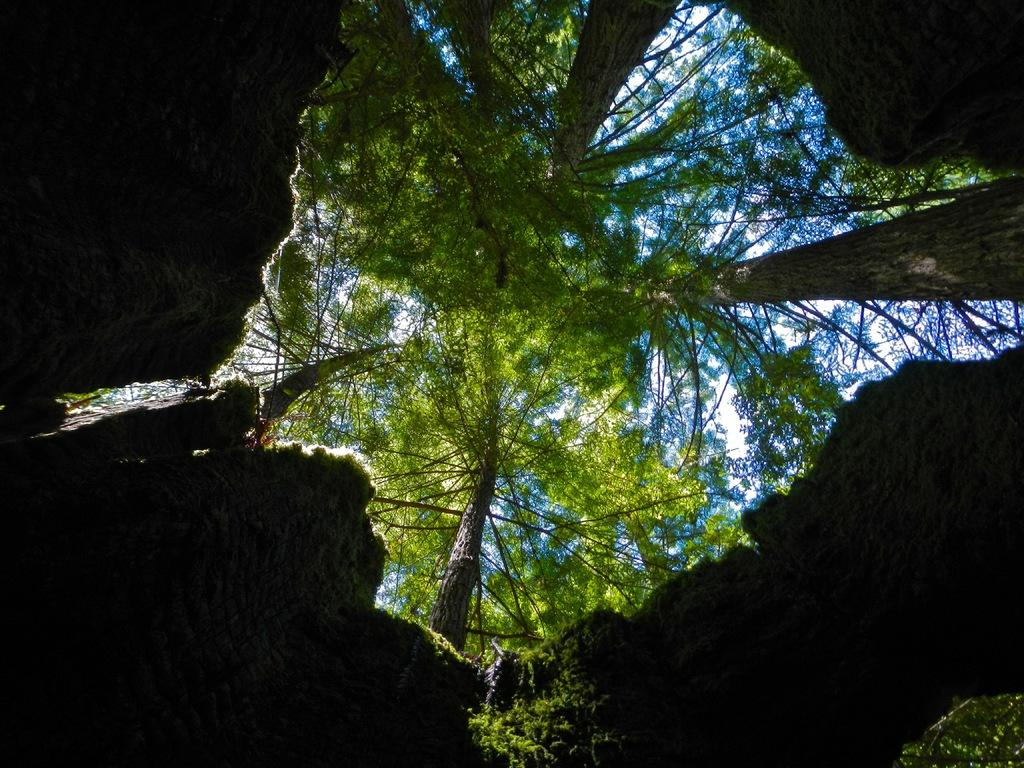What is the perspective of the image? The image is taken from a hole. What can be seen at the top of the image? There are tall trees and the sky visible at the top of the image. What type of play is happening in the image? There is no play or activity visible in the image; it primarily features tall trees and the sky. How does the earth appear in the image? The image does not show the earth as a whole; it only shows a small portion of the landscape from a hole. 